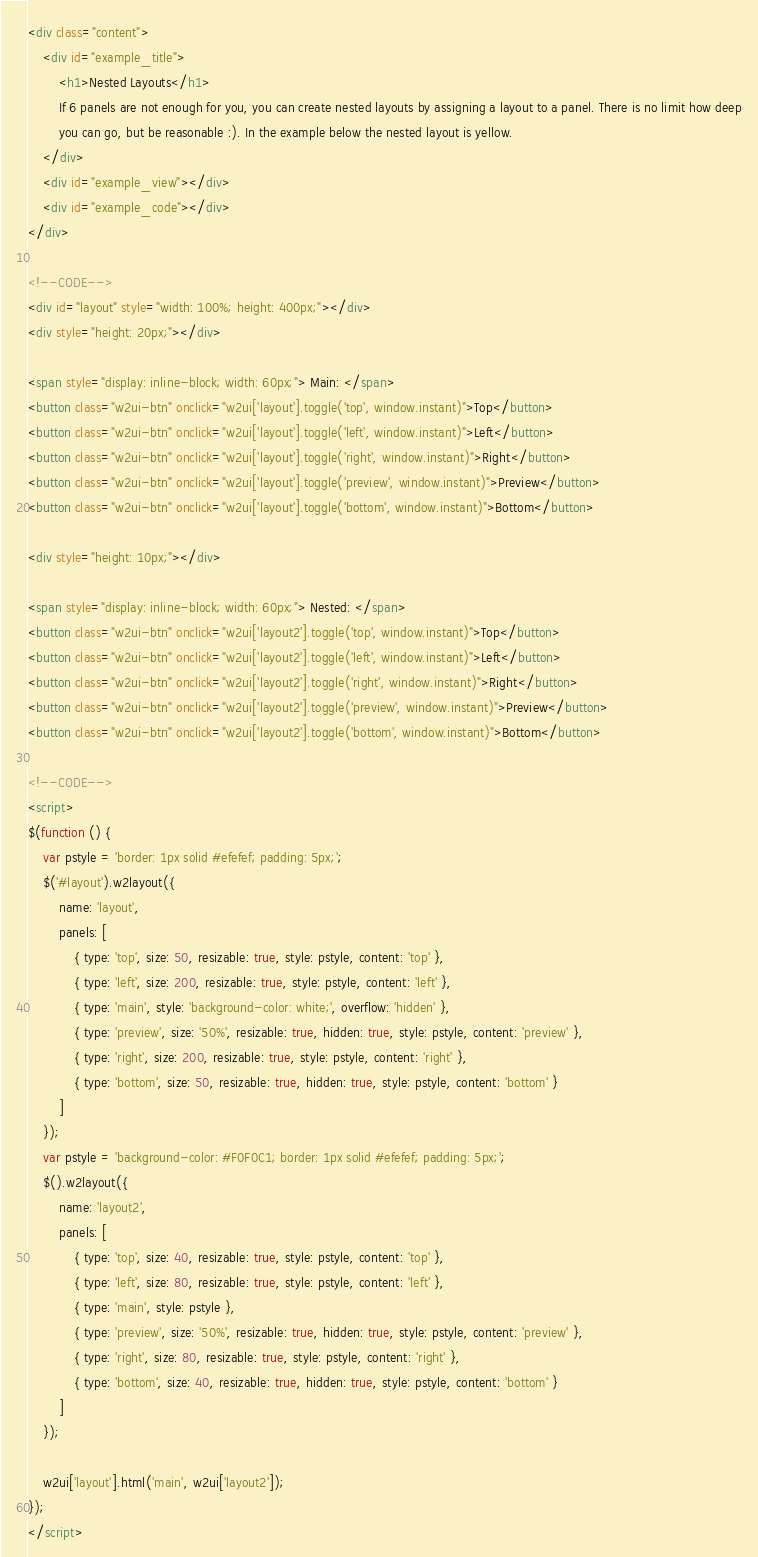<code> <loc_0><loc_0><loc_500><loc_500><_HTML_><div class="content">
    <div id="example_title">
        <h1>Nested Layouts</h1>
        If 6 panels are not enough for you, you can create nested layouts by assigning a layout to a panel. There is no limit how deep
        you can go, but be reasonable :). In the example below the nested layout is yellow.
    </div>
    <div id="example_view"></div>
    <div id="example_code"></div>
</div>

<!--CODE-->
<div id="layout" style="width: 100%; height: 400px;"></div>
<div style="height: 20px;"></div>

<span style="display: inline-block; width: 60px;"> Main: </span>
<button class="w2ui-btn" onclick="w2ui['layout'].toggle('top', window.instant)">Top</button>
<button class="w2ui-btn" onclick="w2ui['layout'].toggle('left', window.instant)">Left</button>
<button class="w2ui-btn" onclick="w2ui['layout'].toggle('right', window.instant)">Right</button>
<button class="w2ui-btn" onclick="w2ui['layout'].toggle('preview', window.instant)">Preview</button>
<button class="w2ui-btn" onclick="w2ui['layout'].toggle('bottom', window.instant)">Bottom</button>

<div style="height: 10px;"></div>

<span style="display: inline-block; width: 60px;"> Nested: </span>
<button class="w2ui-btn" onclick="w2ui['layout2'].toggle('top', window.instant)">Top</button>
<button class="w2ui-btn" onclick="w2ui['layout2'].toggle('left', window.instant)">Left</button>
<button class="w2ui-btn" onclick="w2ui['layout2'].toggle('right', window.instant)">Right</button>
<button class="w2ui-btn" onclick="w2ui['layout2'].toggle('preview', window.instant)">Preview</button>
<button class="w2ui-btn" onclick="w2ui['layout2'].toggle('bottom', window.instant)">Bottom</button>

<!--CODE-->
<script>
$(function () {
    var pstyle = 'border: 1px solid #efefef; padding: 5px;';
    $('#layout').w2layout({
        name: 'layout',
        panels: [
            { type: 'top', size: 50, resizable: true, style: pstyle, content: 'top' },
            { type: 'left', size: 200, resizable: true, style: pstyle, content: 'left' },
            { type: 'main', style: 'background-color: white;', overflow: 'hidden' },
            { type: 'preview', size: '50%', resizable: true, hidden: true, style: pstyle, content: 'preview' },
            { type: 'right', size: 200, resizable: true, style: pstyle, content: 'right' },
            { type: 'bottom', size: 50, resizable: true, hidden: true, style: pstyle, content: 'bottom' }
        ]
    });
    var pstyle = 'background-color: #F0F0C1; border: 1px solid #efefef; padding: 5px;';
    $().w2layout({
        name: 'layout2',
        panels: [
            { type: 'top', size: 40, resizable: true, style: pstyle, content: 'top' },
            { type: 'left', size: 80, resizable: true, style: pstyle, content: 'left' },
            { type: 'main', style: pstyle },
            { type: 'preview', size: '50%', resizable: true, hidden: true, style: pstyle, content: 'preview' },
            { type: 'right', size: 80, resizable: true, style: pstyle, content: 'right' },
            { type: 'bottom', size: 40, resizable: true, hidden: true, style: pstyle, content: 'bottom' }
        ]
    });

    w2ui['layout'].html('main', w2ui['layout2']);
});
</script>
</code> 